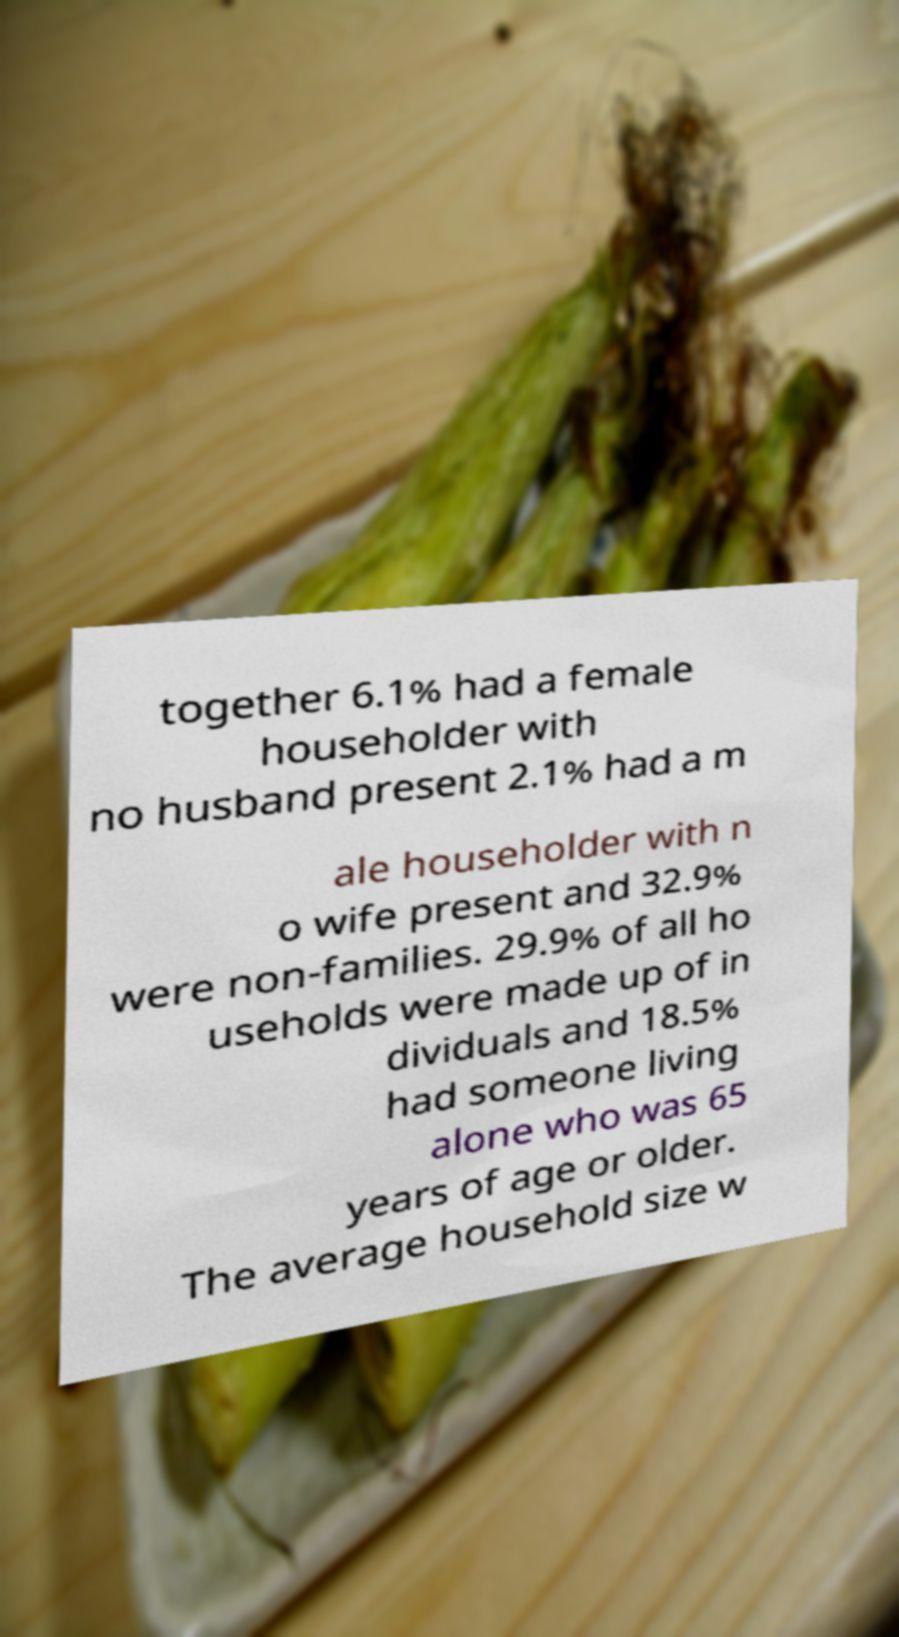For documentation purposes, I need the text within this image transcribed. Could you provide that? together 6.1% had a female householder with no husband present 2.1% had a m ale householder with n o wife present and 32.9% were non-families. 29.9% of all ho useholds were made up of in dividuals and 18.5% had someone living alone who was 65 years of age or older. The average household size w 